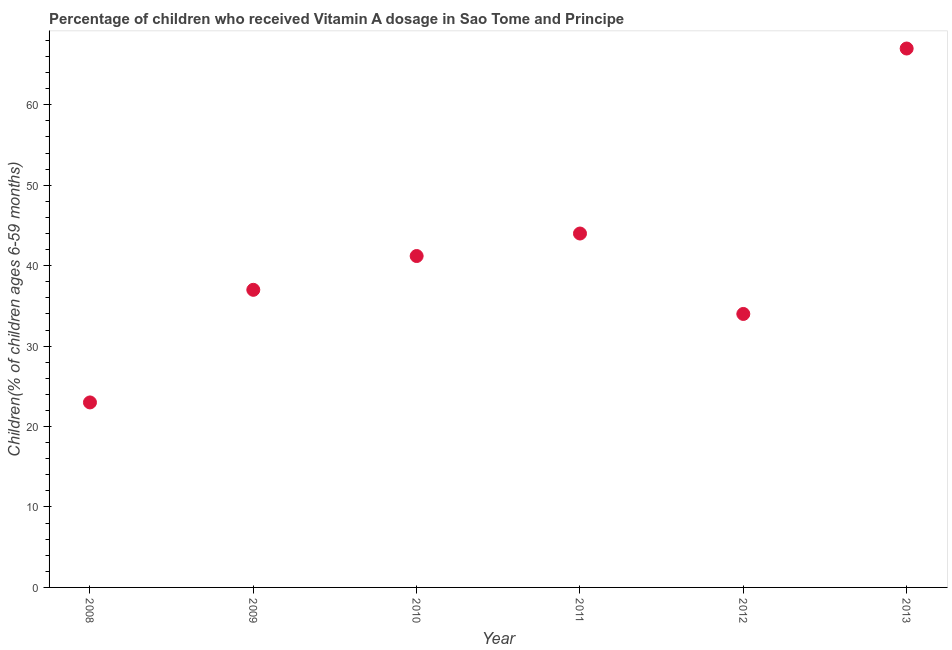What is the vitamin a supplementation coverage rate in 2010?
Your answer should be very brief. 41.2. In which year was the vitamin a supplementation coverage rate maximum?
Make the answer very short. 2013. In which year was the vitamin a supplementation coverage rate minimum?
Your response must be concise. 2008. What is the sum of the vitamin a supplementation coverage rate?
Provide a short and direct response. 246.2. What is the difference between the vitamin a supplementation coverage rate in 2008 and 2011?
Offer a terse response. -21. What is the average vitamin a supplementation coverage rate per year?
Your answer should be compact. 41.03. What is the median vitamin a supplementation coverage rate?
Offer a terse response. 39.1. In how many years, is the vitamin a supplementation coverage rate greater than 58 %?
Your answer should be very brief. 1. Do a majority of the years between 2013 and 2010 (inclusive) have vitamin a supplementation coverage rate greater than 14 %?
Offer a terse response. Yes. What is the ratio of the vitamin a supplementation coverage rate in 2008 to that in 2010?
Your answer should be compact. 0.56. Is the vitamin a supplementation coverage rate in 2008 less than that in 2011?
Offer a terse response. Yes. What is the difference between the highest and the second highest vitamin a supplementation coverage rate?
Make the answer very short. 23. What is the difference between two consecutive major ticks on the Y-axis?
Provide a succinct answer. 10. Does the graph contain any zero values?
Your answer should be compact. No. Does the graph contain grids?
Make the answer very short. No. What is the title of the graph?
Your response must be concise. Percentage of children who received Vitamin A dosage in Sao Tome and Principe. What is the label or title of the Y-axis?
Your answer should be compact. Children(% of children ages 6-59 months). What is the Children(% of children ages 6-59 months) in 2008?
Offer a very short reply. 23. What is the Children(% of children ages 6-59 months) in 2009?
Offer a terse response. 37. What is the Children(% of children ages 6-59 months) in 2010?
Your answer should be compact. 41.2. What is the Children(% of children ages 6-59 months) in 2011?
Offer a very short reply. 44. What is the Children(% of children ages 6-59 months) in 2013?
Give a very brief answer. 67. What is the difference between the Children(% of children ages 6-59 months) in 2008 and 2010?
Your answer should be very brief. -18.2. What is the difference between the Children(% of children ages 6-59 months) in 2008 and 2011?
Make the answer very short. -21. What is the difference between the Children(% of children ages 6-59 months) in 2008 and 2012?
Offer a terse response. -11. What is the difference between the Children(% of children ages 6-59 months) in 2008 and 2013?
Ensure brevity in your answer.  -44. What is the difference between the Children(% of children ages 6-59 months) in 2009 and 2010?
Provide a succinct answer. -4.2. What is the difference between the Children(% of children ages 6-59 months) in 2009 and 2012?
Ensure brevity in your answer.  3. What is the difference between the Children(% of children ages 6-59 months) in 2009 and 2013?
Your answer should be very brief. -30. What is the difference between the Children(% of children ages 6-59 months) in 2010 and 2011?
Offer a terse response. -2.8. What is the difference between the Children(% of children ages 6-59 months) in 2010 and 2012?
Provide a succinct answer. 7.2. What is the difference between the Children(% of children ages 6-59 months) in 2010 and 2013?
Your answer should be compact. -25.8. What is the difference between the Children(% of children ages 6-59 months) in 2011 and 2012?
Offer a very short reply. 10. What is the difference between the Children(% of children ages 6-59 months) in 2012 and 2013?
Ensure brevity in your answer.  -33. What is the ratio of the Children(% of children ages 6-59 months) in 2008 to that in 2009?
Your answer should be compact. 0.62. What is the ratio of the Children(% of children ages 6-59 months) in 2008 to that in 2010?
Offer a very short reply. 0.56. What is the ratio of the Children(% of children ages 6-59 months) in 2008 to that in 2011?
Give a very brief answer. 0.52. What is the ratio of the Children(% of children ages 6-59 months) in 2008 to that in 2012?
Your response must be concise. 0.68. What is the ratio of the Children(% of children ages 6-59 months) in 2008 to that in 2013?
Your answer should be compact. 0.34. What is the ratio of the Children(% of children ages 6-59 months) in 2009 to that in 2010?
Offer a very short reply. 0.9. What is the ratio of the Children(% of children ages 6-59 months) in 2009 to that in 2011?
Your answer should be very brief. 0.84. What is the ratio of the Children(% of children ages 6-59 months) in 2009 to that in 2012?
Make the answer very short. 1.09. What is the ratio of the Children(% of children ages 6-59 months) in 2009 to that in 2013?
Your answer should be very brief. 0.55. What is the ratio of the Children(% of children ages 6-59 months) in 2010 to that in 2011?
Your response must be concise. 0.94. What is the ratio of the Children(% of children ages 6-59 months) in 2010 to that in 2012?
Your response must be concise. 1.21. What is the ratio of the Children(% of children ages 6-59 months) in 2010 to that in 2013?
Your response must be concise. 0.61. What is the ratio of the Children(% of children ages 6-59 months) in 2011 to that in 2012?
Make the answer very short. 1.29. What is the ratio of the Children(% of children ages 6-59 months) in 2011 to that in 2013?
Your response must be concise. 0.66. What is the ratio of the Children(% of children ages 6-59 months) in 2012 to that in 2013?
Offer a very short reply. 0.51. 